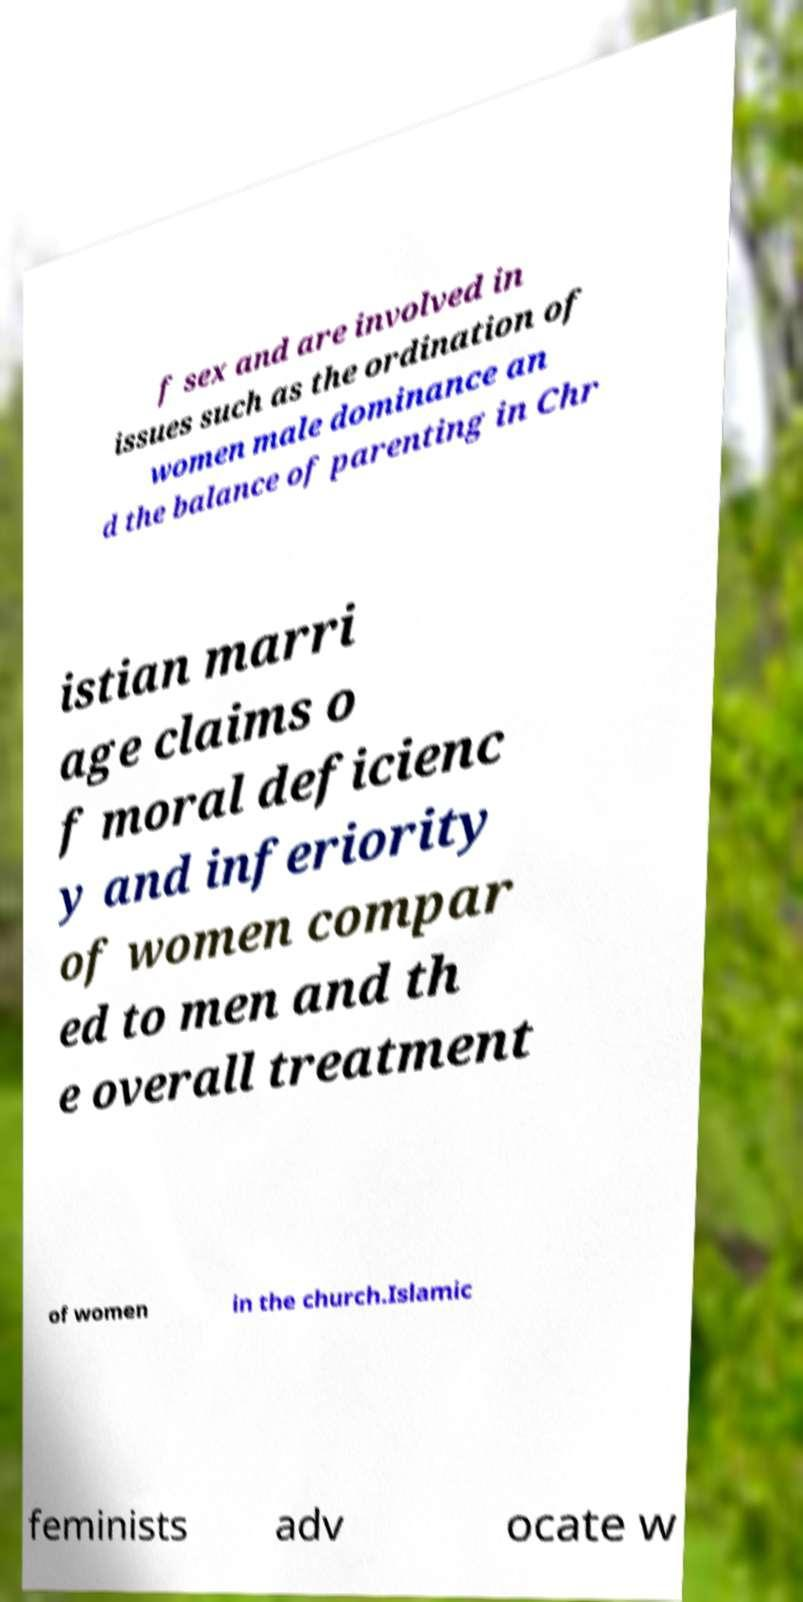Can you accurately transcribe the text from the provided image for me? f sex and are involved in issues such as the ordination of women male dominance an d the balance of parenting in Chr istian marri age claims o f moral deficienc y and inferiority of women compar ed to men and th e overall treatment of women in the church.Islamic feminists adv ocate w 